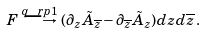Convert formula to latex. <formula><loc_0><loc_0><loc_500><loc_500>F \stackrel { q \ r p 1 } { \longrightarrow } ( \partial _ { z } \tilde { A } _ { \overline { z } } - \partial _ { \overline { z } } \tilde { A } _ { z } ) d z d \overline { z } \, .</formula> 